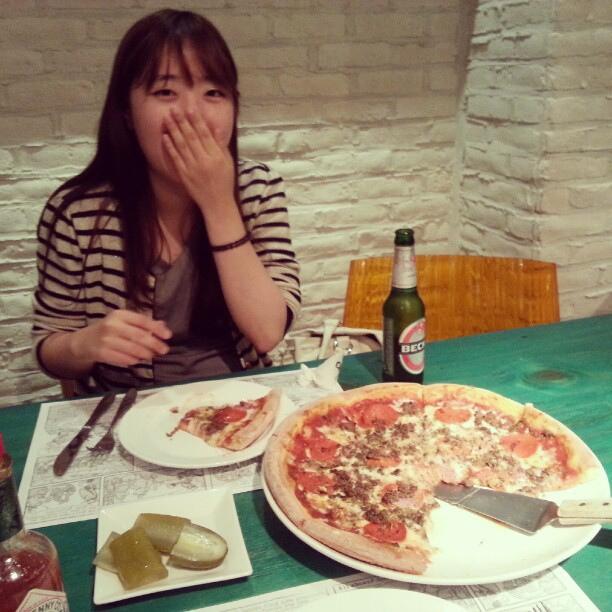What type of pizza is it?
Keep it brief. Pepperoni. What is the lady drinking with her pizza?
Be succinct. Beer. Where is the tabasco sauce?
Be succinct. Table. 